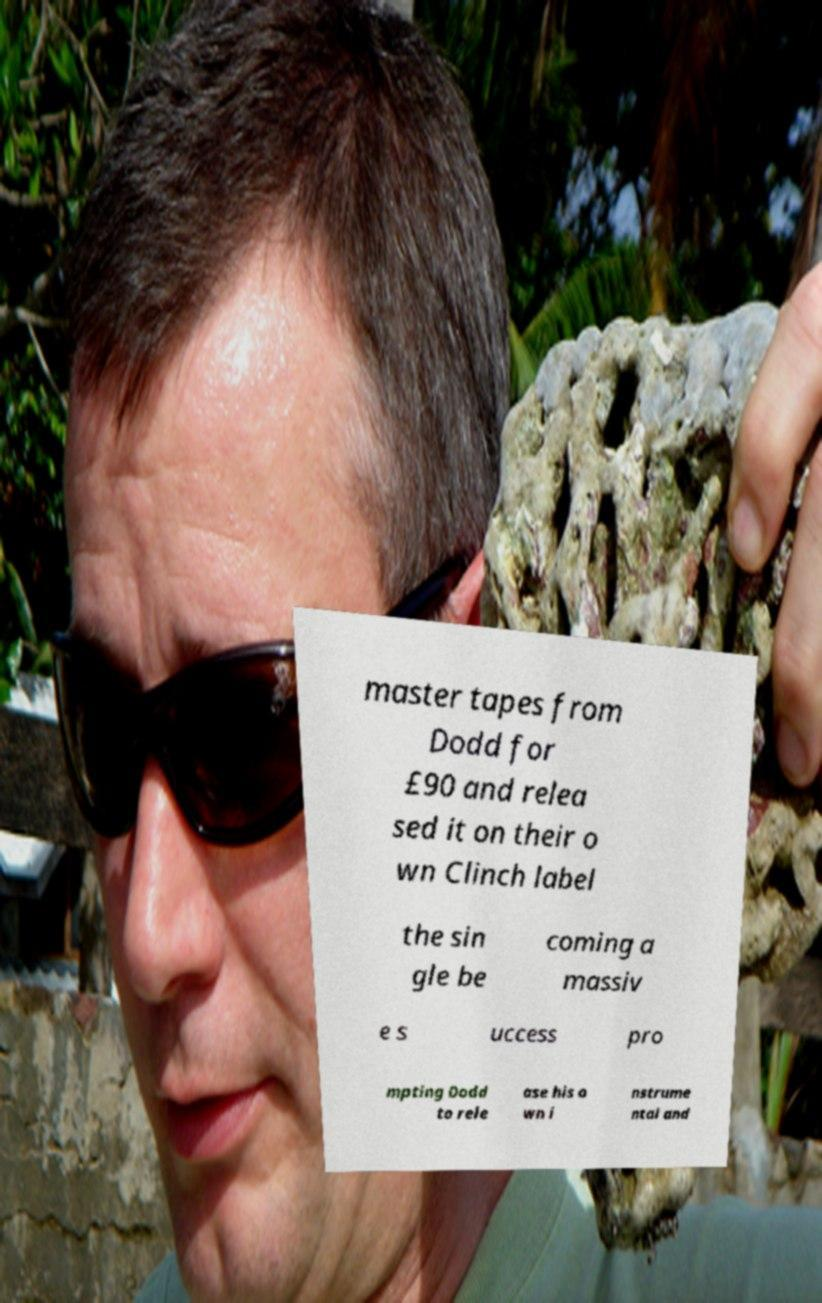For documentation purposes, I need the text within this image transcribed. Could you provide that? master tapes from Dodd for £90 and relea sed it on their o wn Clinch label the sin gle be coming a massiv e s uccess pro mpting Dodd to rele ase his o wn i nstrume ntal and 